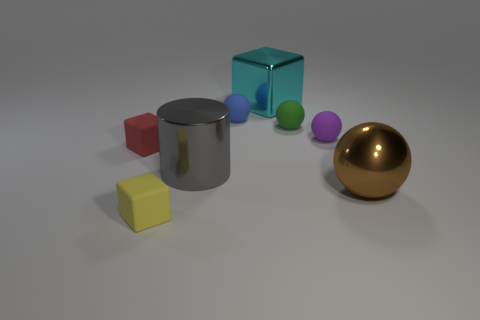Subtract all big cyan shiny cubes. How many cubes are left? 2 Subtract all blue spheres. How many spheres are left? 3 Add 1 blue cylinders. How many objects exist? 9 Subtract 3 balls. How many balls are left? 1 Subtract all cylinders. How many objects are left? 7 Subtract all yellow cylinders. Subtract all green spheres. How many cylinders are left? 1 Subtract all cyan blocks. How many blue balls are left? 1 Subtract 1 green spheres. How many objects are left? 7 Subtract all tiny purple matte spheres. Subtract all blue rubber blocks. How many objects are left? 7 Add 7 green matte balls. How many green matte balls are left? 8 